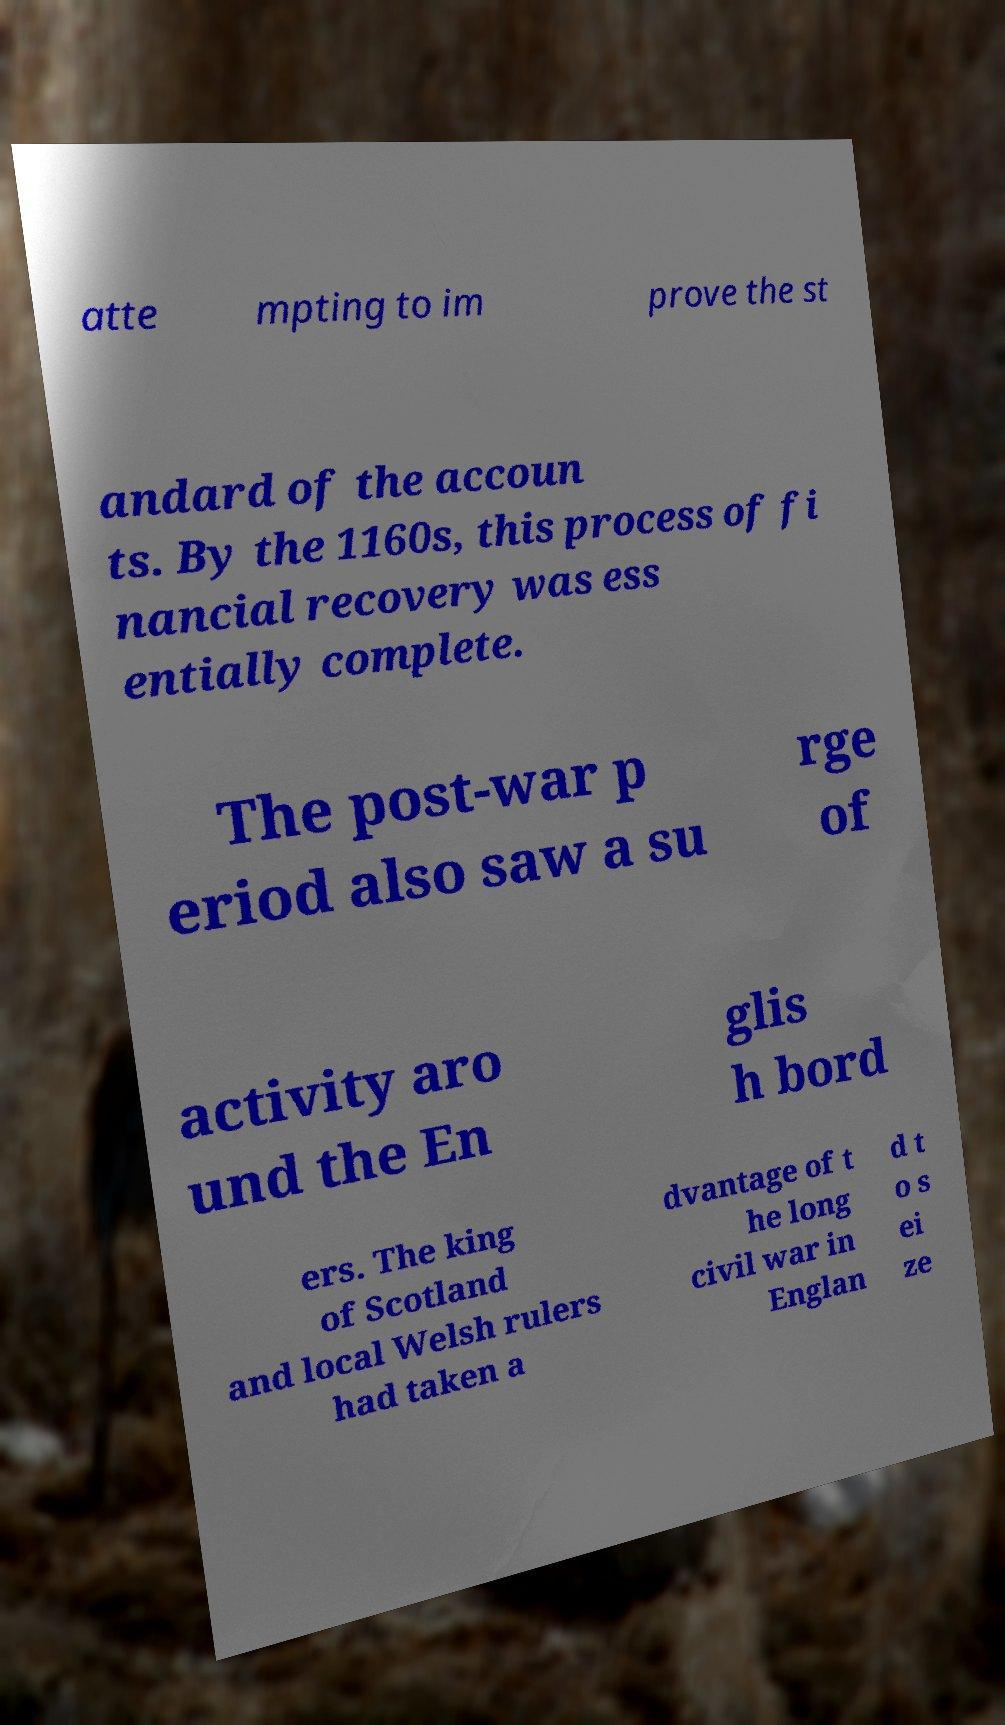Please identify and transcribe the text found in this image. atte mpting to im prove the st andard of the accoun ts. By the 1160s, this process of fi nancial recovery was ess entially complete. The post-war p eriod also saw a su rge of activity aro und the En glis h bord ers. The king of Scotland and local Welsh rulers had taken a dvantage of t he long civil war in Englan d t o s ei ze 